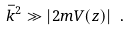<formula> <loc_0><loc_0><loc_500><loc_500>\bar { k } ^ { 2 } \gg | 2 m V ( z ) | \ .</formula> 